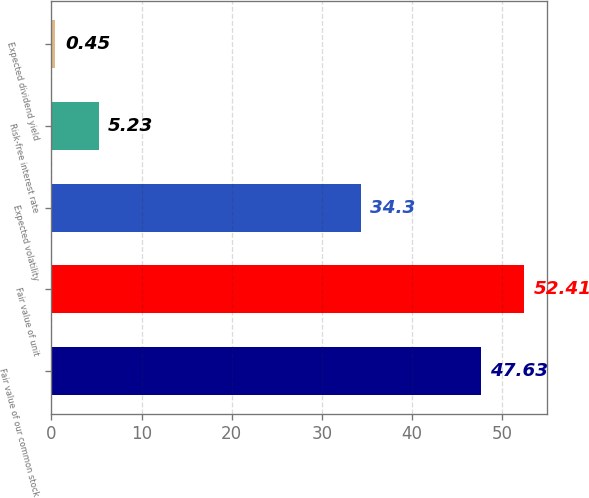Convert chart. <chart><loc_0><loc_0><loc_500><loc_500><bar_chart><fcel>Fair value of our common stock<fcel>Fair value of unit<fcel>Expected volatility<fcel>Risk-free interest rate<fcel>Expected dividend yield<nl><fcel>47.63<fcel>52.41<fcel>34.3<fcel>5.23<fcel>0.45<nl></chart> 